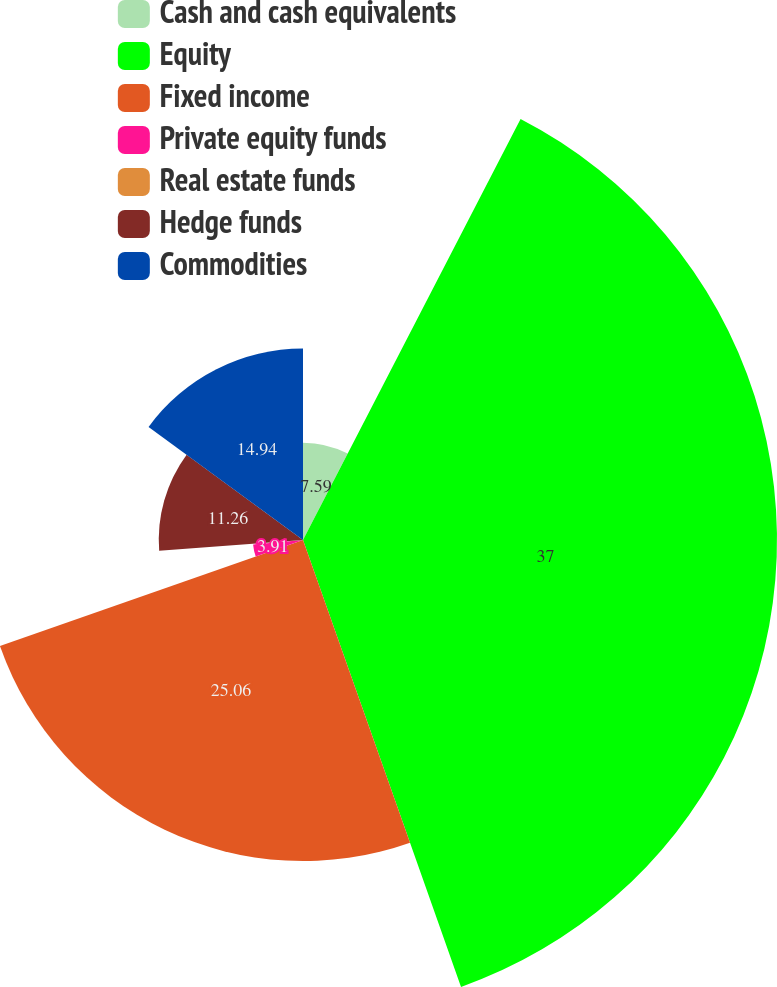<chart> <loc_0><loc_0><loc_500><loc_500><pie_chart><fcel>Cash and cash equivalents<fcel>Equity<fcel>Fixed income<fcel>Private equity funds<fcel>Real estate funds<fcel>Hedge funds<fcel>Commodities<nl><fcel>7.59%<fcel>37.0%<fcel>25.06%<fcel>3.91%<fcel>0.24%<fcel>11.26%<fcel>14.94%<nl></chart> 